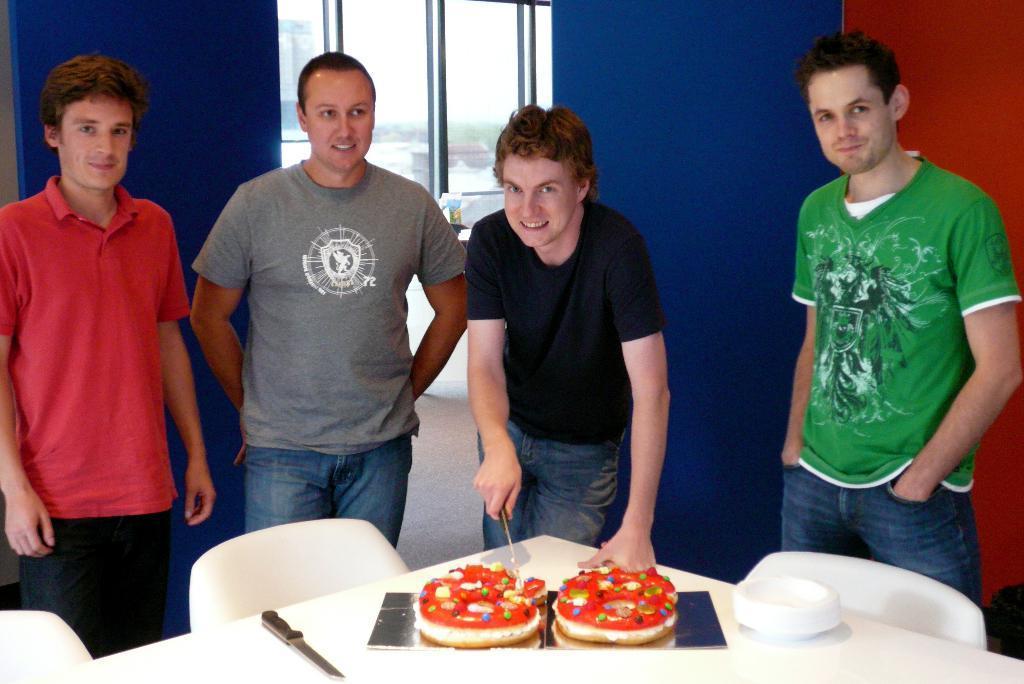Could you give a brief overview of what you see in this image? In this image there is a person holding a knife is cutting a cake on the table. On the table there are some other objects. In front of the table there are chairs, beside the person there are a few people standing. Behind him there is a glass window on the wall, through the window we can see trees and buildings on the outside. 